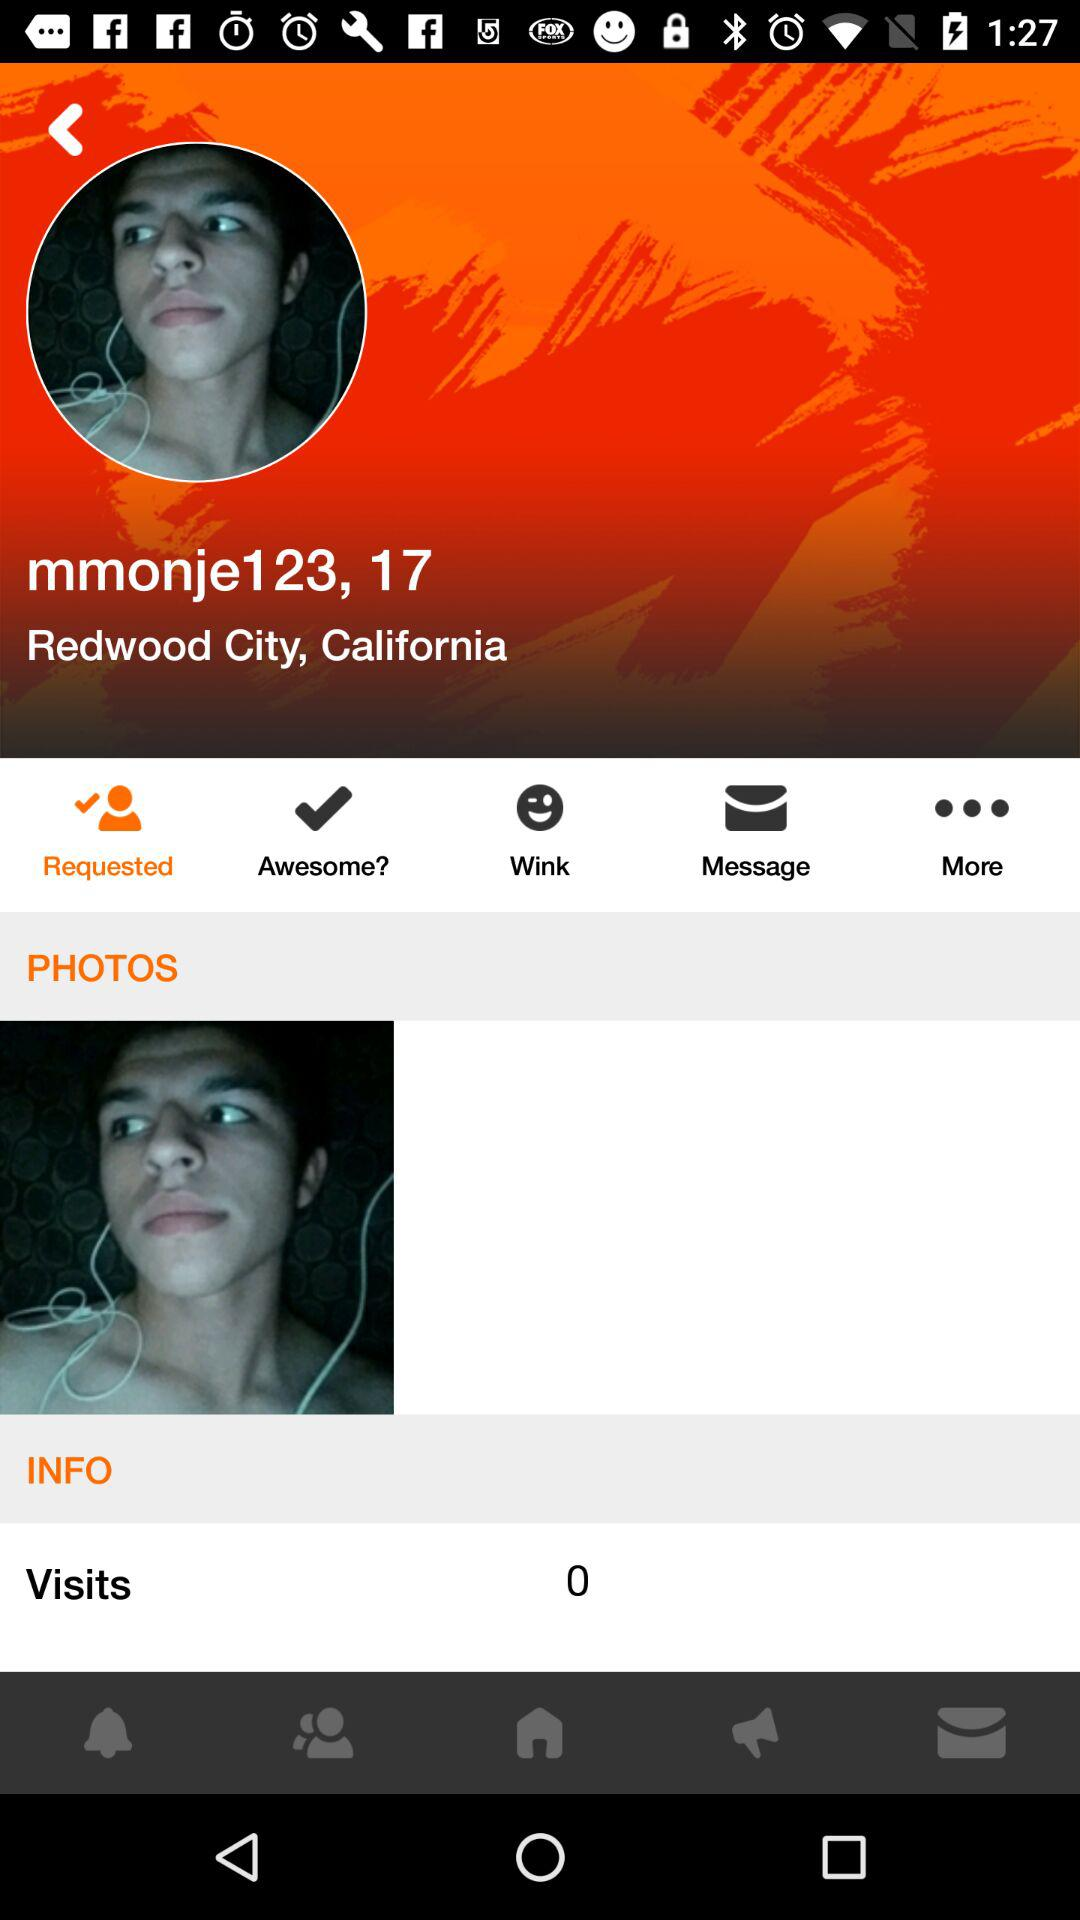What is the username? The username is "mmonje123". 